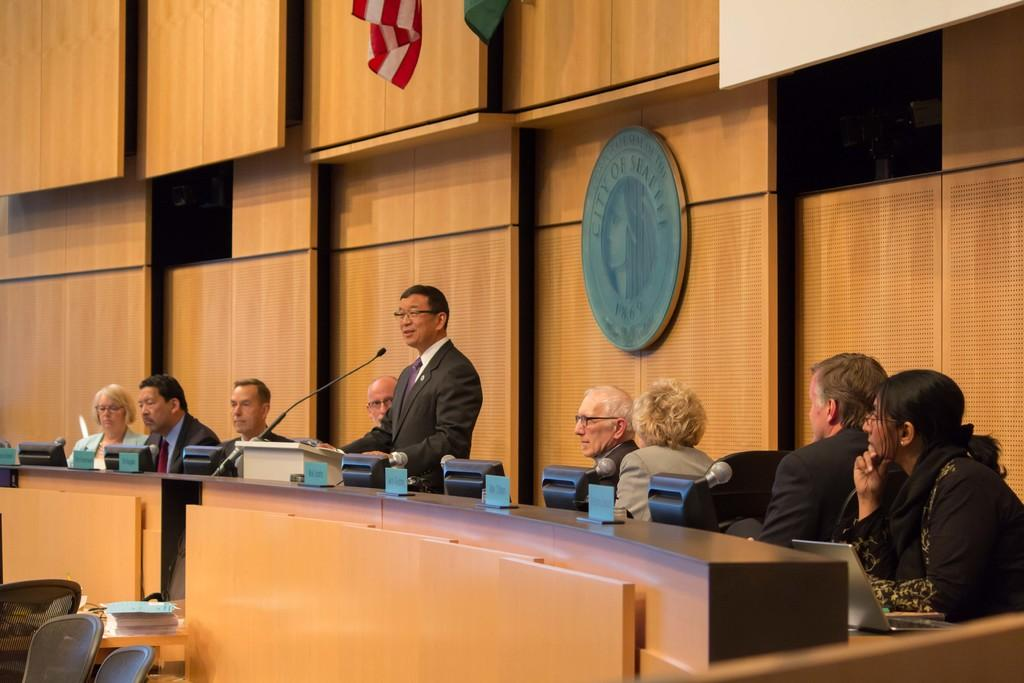What are the people in the image doing? There is a group of people sitting on chairs, and a person standing and speaking. What might the standing person be using to amplify their voice? A microphone is present in front of the standing person. What is located at the back of the scene? There is a wall at the back of the scene. What type of road can be seen in the image? There is no road present in the image. How does the standing person blow air into the microphone in the image? The standing person is not blowing air into the microphone in the image; they are using it to amplify their voice. 